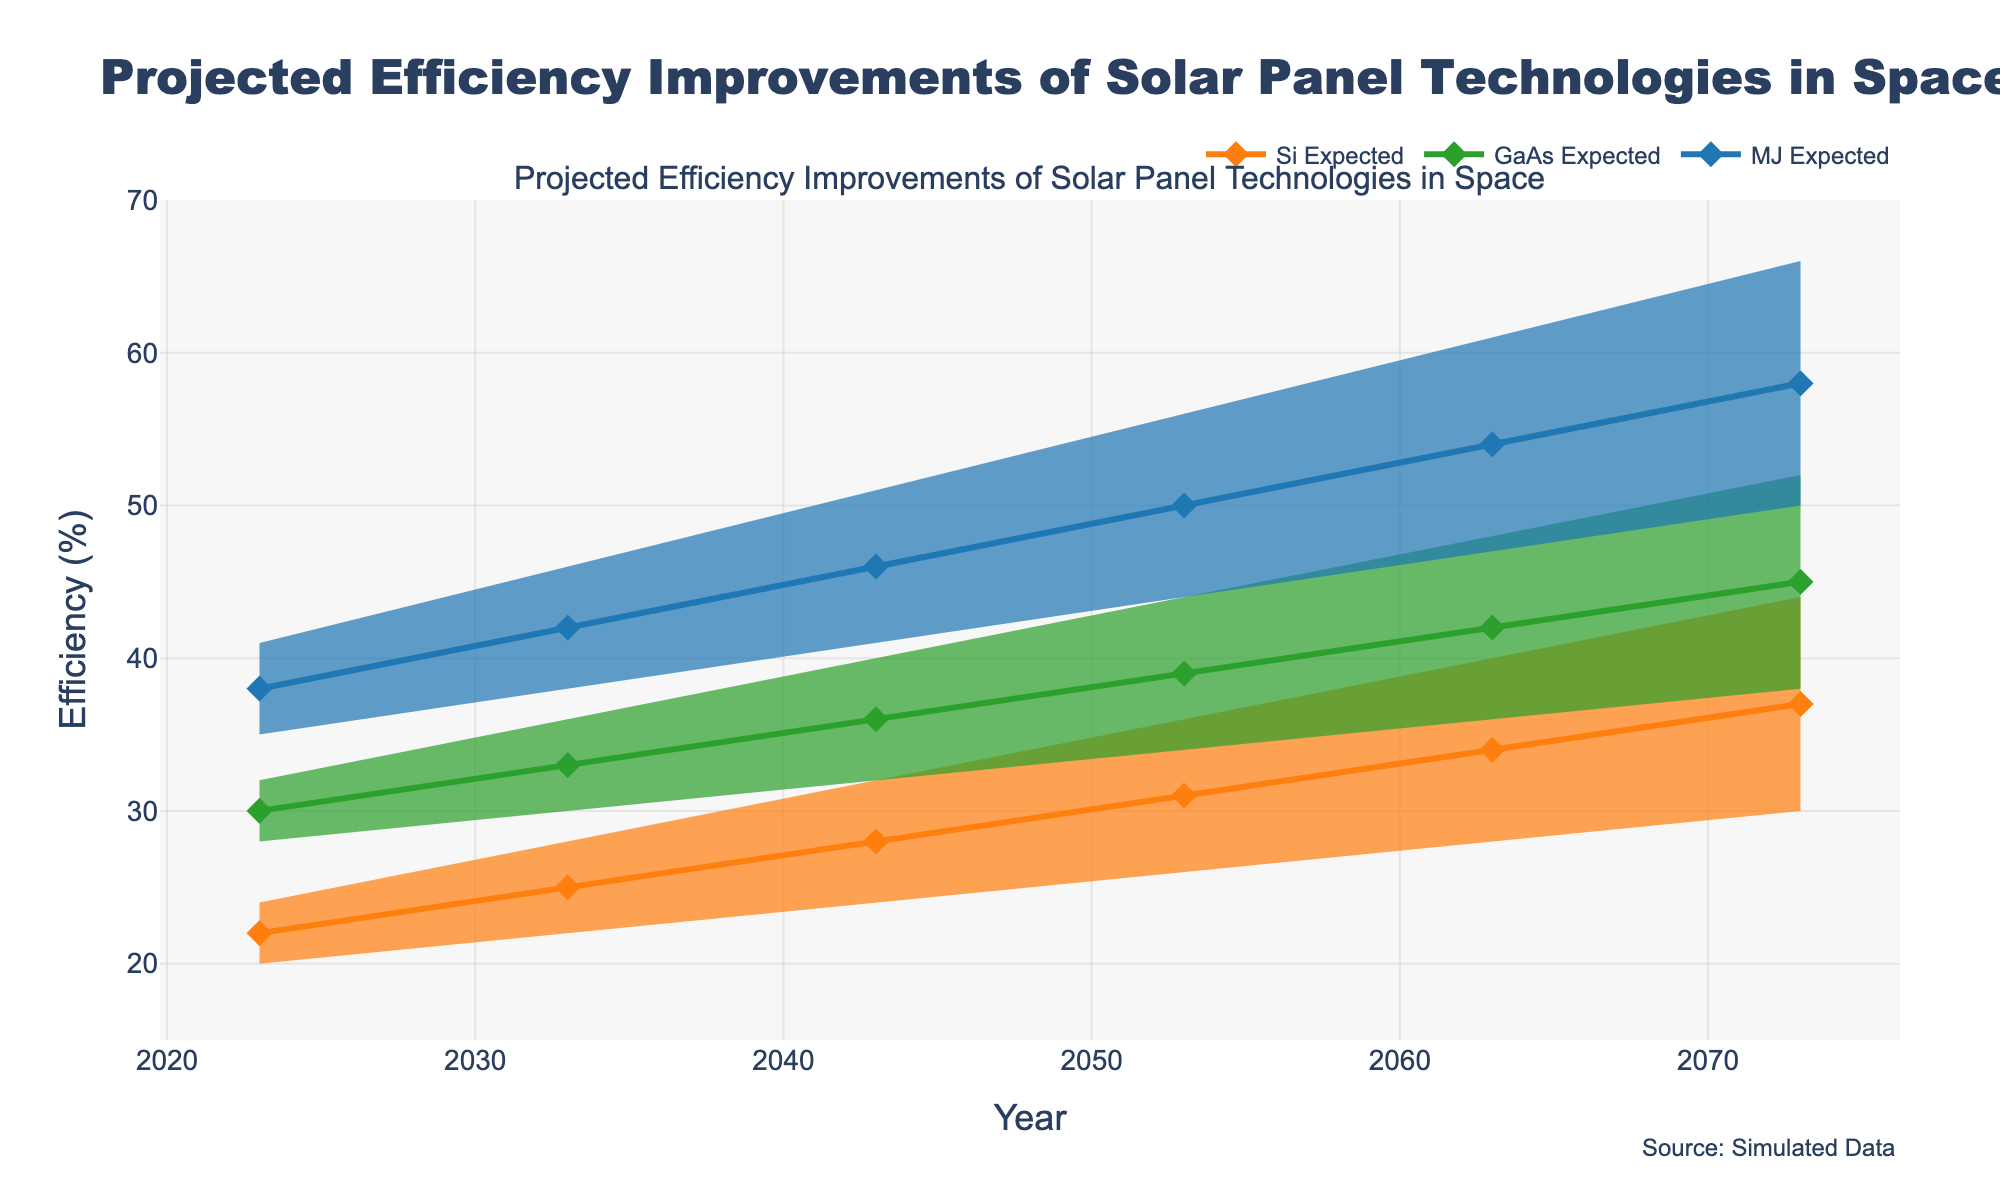What is the title of the chart? The title of the chart is located at the top center of the figure, which describes the main content of the chart. In this case, it is "Projected Efficiency Improvements of Solar Panel Technologies in Space".
Answer: Projected Efficiency Improvements of Solar Panel Technologies in Space What does the y-axis represent? The y-axis label is "Efficiency (%)", indicating that the vertical axis measures the efficiency percentage of the solar panels.
Answer: Efficiency (%) What is the expected efficiency of GaAs technology in the year 2053? The expected efficiency for GaAs technology can be found by locating the year 2053 on the x-axis and checking the corresponding point for the GaAs Expected line, which is placed at 39%.
Answer: 39% Among Si, GaAs, and MJ technologies, which one has the highest expected efficiency in the year 2073? Comparing the expected efficiency values of the three technologies for the year 2073, MJ technology shows the highest expected efficiency at 58%.
Answer: MJ By how much is the low efficiency of Si expected to increase from 2023 to 2073? The low efficiency of Si in 2023 is 20%, and in 2073 it is 30%. The difference is calculated as 30% - 20% = 10%.
Answer: 10% Which technology shows the widest range of efficiency projections in the year 2063? The range is calculated by subtracting the low efficiency from the high efficiency for each technology in the year 2063. MJ shows the widest range with 61% - 47% = 14%.
Answer: MJ What is the highest expected efficiency value for all technologies in the year 2063? To find the highest expected efficiency for 2063, compare the expected values for Si (34%), GaAs (42%), and MJ (54%). The highest value is 54% for MJ technology.
Answer: 54% Which technology has the smallest increase in expected efficiency from 2023 to 2073? Calculate the increase in expected efficiency for each technology by subtracting the 2023 value from the 2073 value: Si (37% - 22% = 15%), GaAs (45% - 30% = 15%), and MJ (58% - 38% = 20%). Si and GaAs have the smallest increase, both at 15%.
Answer: Si and GaAs How does the expected efficiency of Si technology change over the 50 years? Checking the data points across the years for Si technology, the efficiency increases from 22% in 2023 to 37% in 2073. This indicates a gradual improvement in efficiency over time.
Answer: Gradual increase 